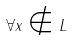Convert formula to latex. <formula><loc_0><loc_0><loc_500><loc_500>\forall x \notin L</formula> 